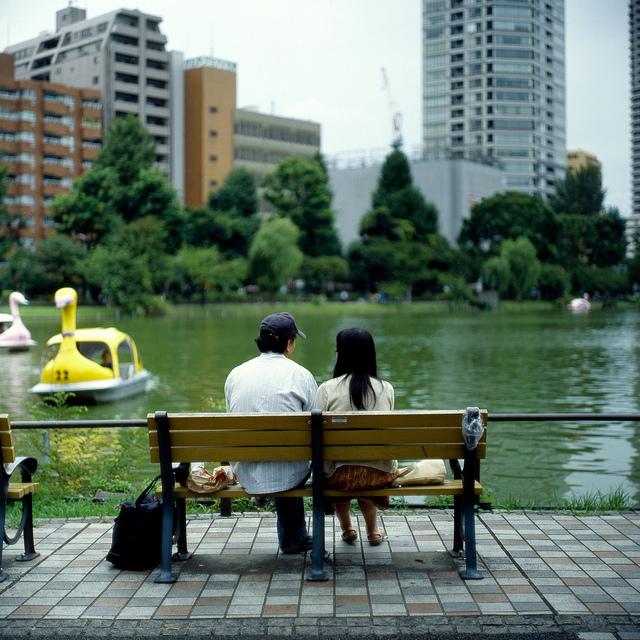How many people are sitting on the bench?
Write a very short answer. 2. Is a crane in view?
Short answer required. Yes. Are they watching the water?
Keep it brief. Yes. 